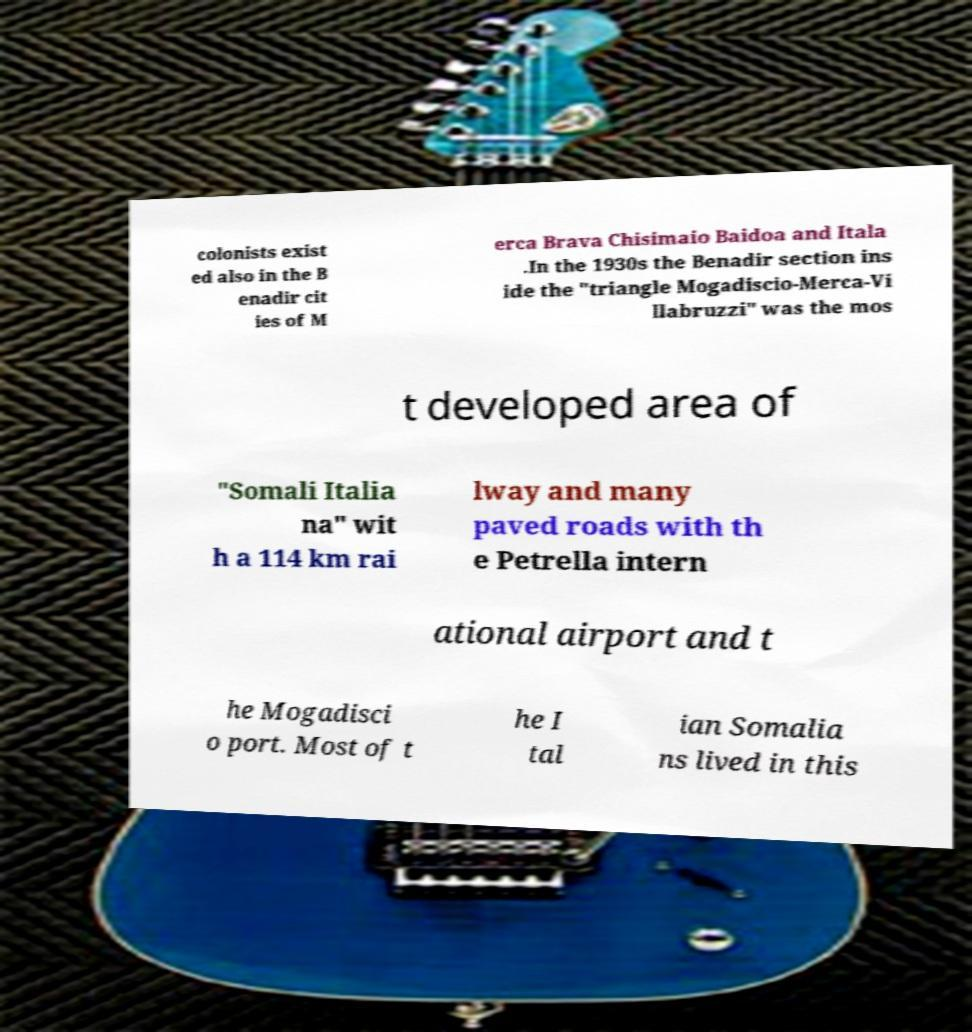I need the written content from this picture converted into text. Can you do that? colonists exist ed also in the B enadir cit ies of M erca Brava Chisimaio Baidoa and Itala .In the 1930s the Benadir section ins ide the "triangle Mogadiscio-Merca-Vi llabruzzi" was the mos t developed area of "Somali Italia na" wit h a 114 km rai lway and many paved roads with th e Petrella intern ational airport and t he Mogadisci o port. Most of t he I tal ian Somalia ns lived in this 